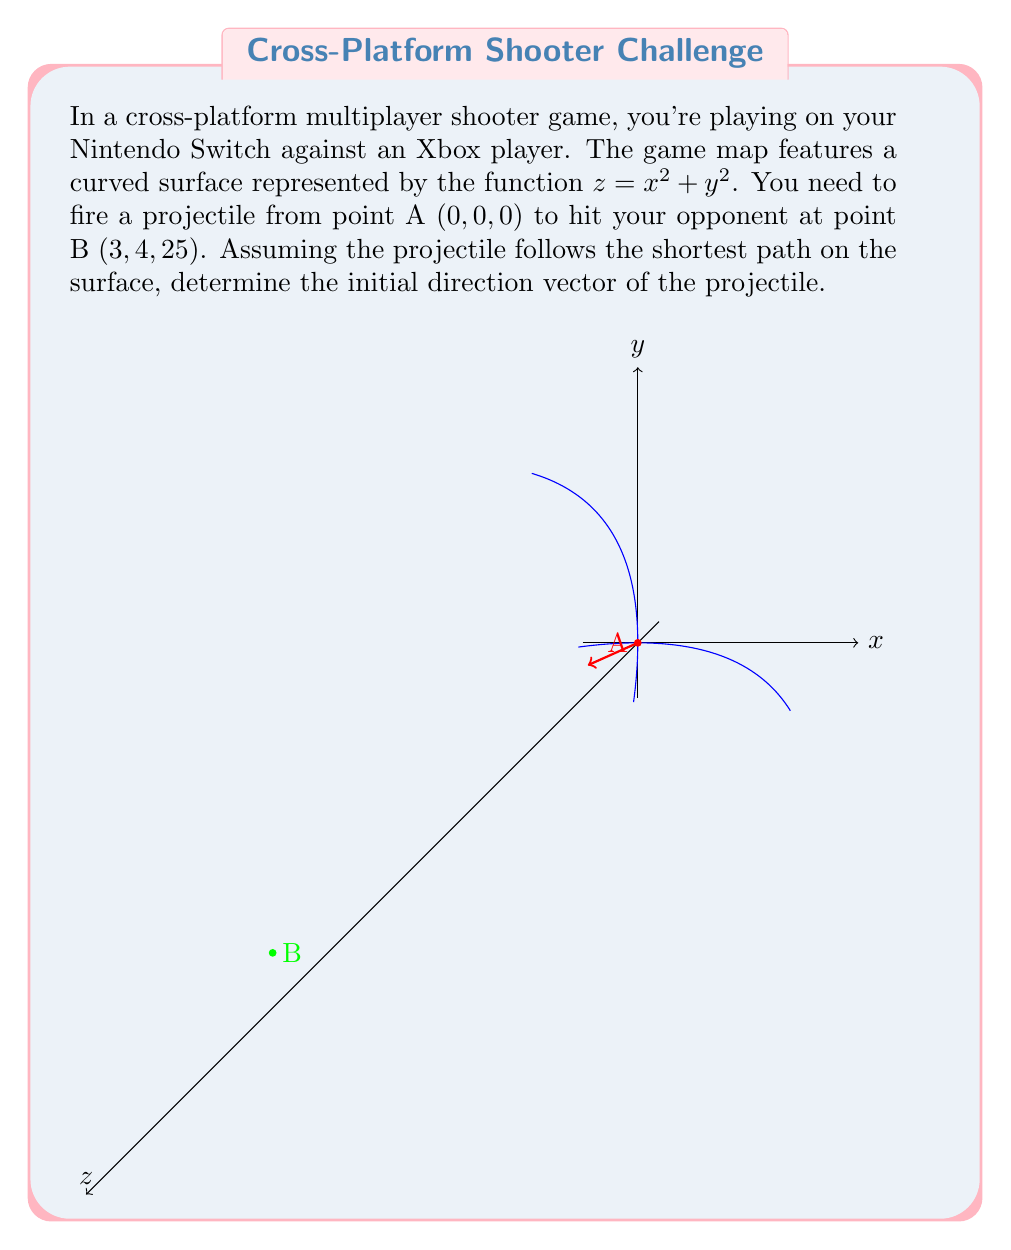Can you solve this math problem? To solve this problem, we need to use the theory of geodesics on manifolds. The shortest path between two points on a curved surface is called a geodesic. For a surface defined by $z = f(x,y)$, we can use the Euler-Lagrange equations to find the geodesic.

Step 1: Define the surface and parametrize the path.
The surface is given by $z = x^2 + y^2$. Let's parametrize the path as $(x(t), y(t), z(t))$ where $z(t) = x(t)^2 + y(t)^2$.

Step 2: Set up the Euler-Lagrange equations.
The Lagrangian for this problem is:
$$L = \sqrt{1 + (\frac{dx}{dt})^2 + (\frac{dy}{dt})^2 + (\frac{dz}{dt})^2}$$
$$= \sqrt{1 + (\frac{dx}{dt})^2 + (\frac{dy}{dt})^2 + (2x\frac{dx}{dt} + 2y\frac{dy}{dt})^2}$$

Step 3: Solve the Euler-Lagrange equations.
The Euler-Lagrange equations are:
$$\frac{d}{dt}(\frac{\partial L}{\partial \dot{x}}) = \frac{\partial L}{\partial x}$$
$$\frac{d}{dt}(\frac{\partial L}{\partial \dot{y}}) = \frac{\partial L}{\partial y}$$

These equations are complex and typically require numerical methods to solve.

Step 4: Initial direction vector.
Since we only need the initial direction vector, we can approximate it using the tangent plane at point A. The normal vector to the surface at A $(0,0,0)$ is:
$$\vec{n} = (2x, 2y, -1)|_{(0,0,0)} = (0, 0, -1)$$

The vector from A to B is $\vec{v} = (3, 4, 25)$. We project this onto the tangent plane:
$$\vec{v}_{\text{proj}} = \vec{v} - (\vec{v} \cdot \hat{n})\hat{n} = (3, 4, 25) - (25)(0, 0, -1) = (3, 4, 0)$$

Step 5: Normalize the direction vector.
$$\vec{d} = \frac{\vec{v}_{\text{proj}}}{|\vec{v}_{\text{proj}}|} = \frac{(3, 4, 0)}{\sqrt{3^2 + 4^2}} = (\frac{3}{5}, \frac{4}{5}, 0)$$
Answer: $(\frac{3}{5}, \frac{4}{5}, 0)$ 